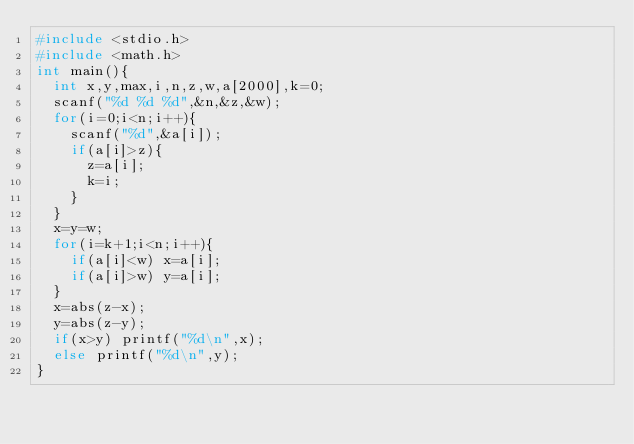<code> <loc_0><loc_0><loc_500><loc_500><_C_>#include <stdio.h>
#include <math.h>
int main(){
	int x,y,max,i,n,z,w,a[2000],k=0;
	scanf("%d %d %d",&n,&z,&w);
	for(i=0;i<n;i++){
		scanf("%d",&a[i]);
		if(a[i]>z){
			z=a[i];
			k=i;
		}
	}
	x=y=w;
	for(i=k+1;i<n;i++){
		if(a[i]<w) x=a[i];
		if(a[i]>w) y=a[i];
	}
	x=abs(z-x);
	y=abs(z-y);
	if(x>y) printf("%d\n",x);
	else printf("%d\n",y);
}</code> 